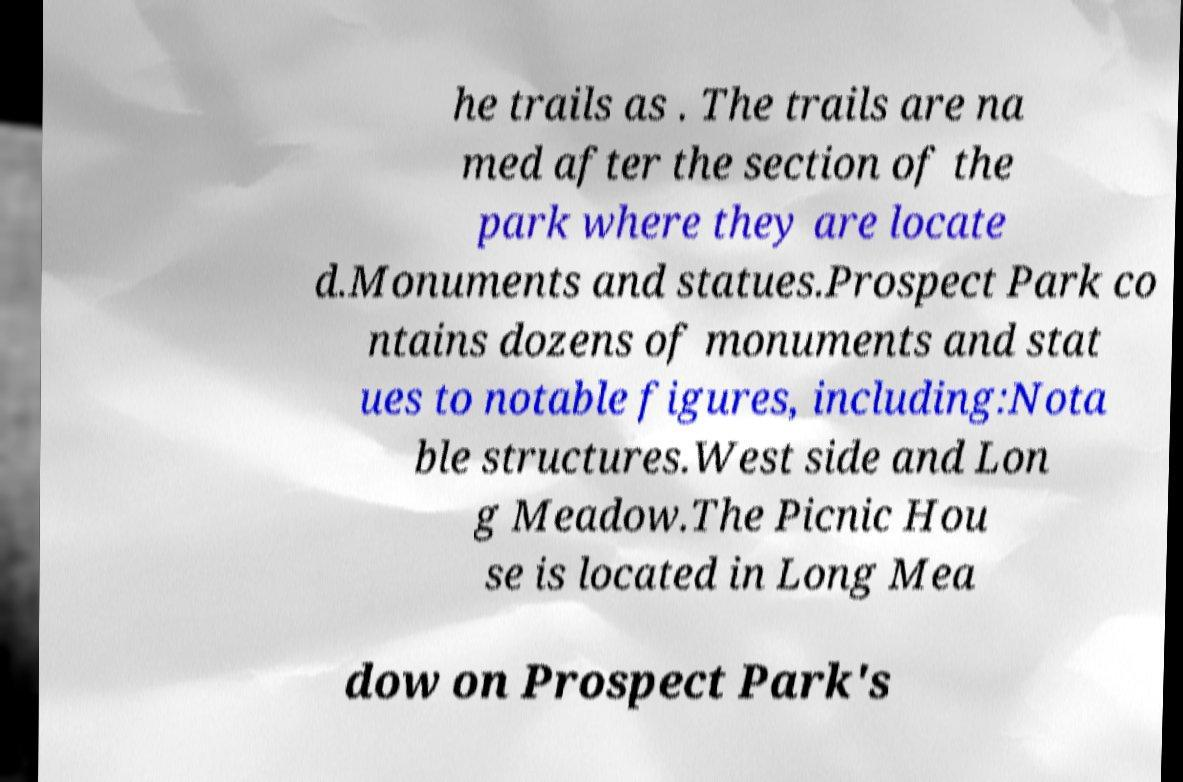Please identify and transcribe the text found in this image. he trails as . The trails are na med after the section of the park where they are locate d.Monuments and statues.Prospect Park co ntains dozens of monuments and stat ues to notable figures, including:Nota ble structures.West side and Lon g Meadow.The Picnic Hou se is located in Long Mea dow on Prospect Park's 